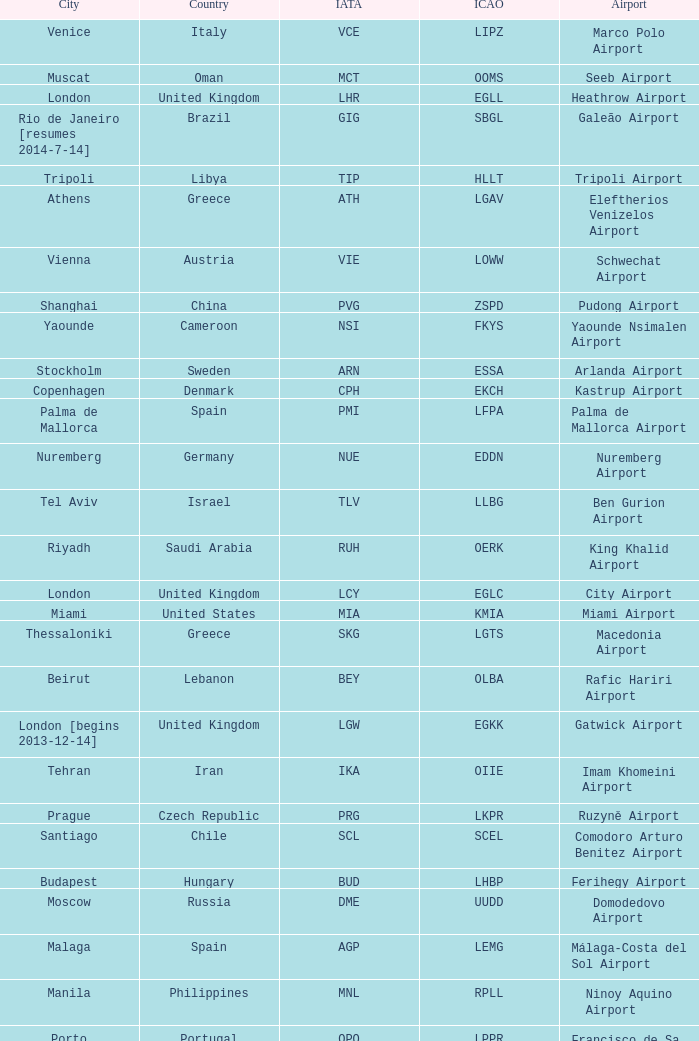What city is fuhlsbüttel airport in? Hamburg. 